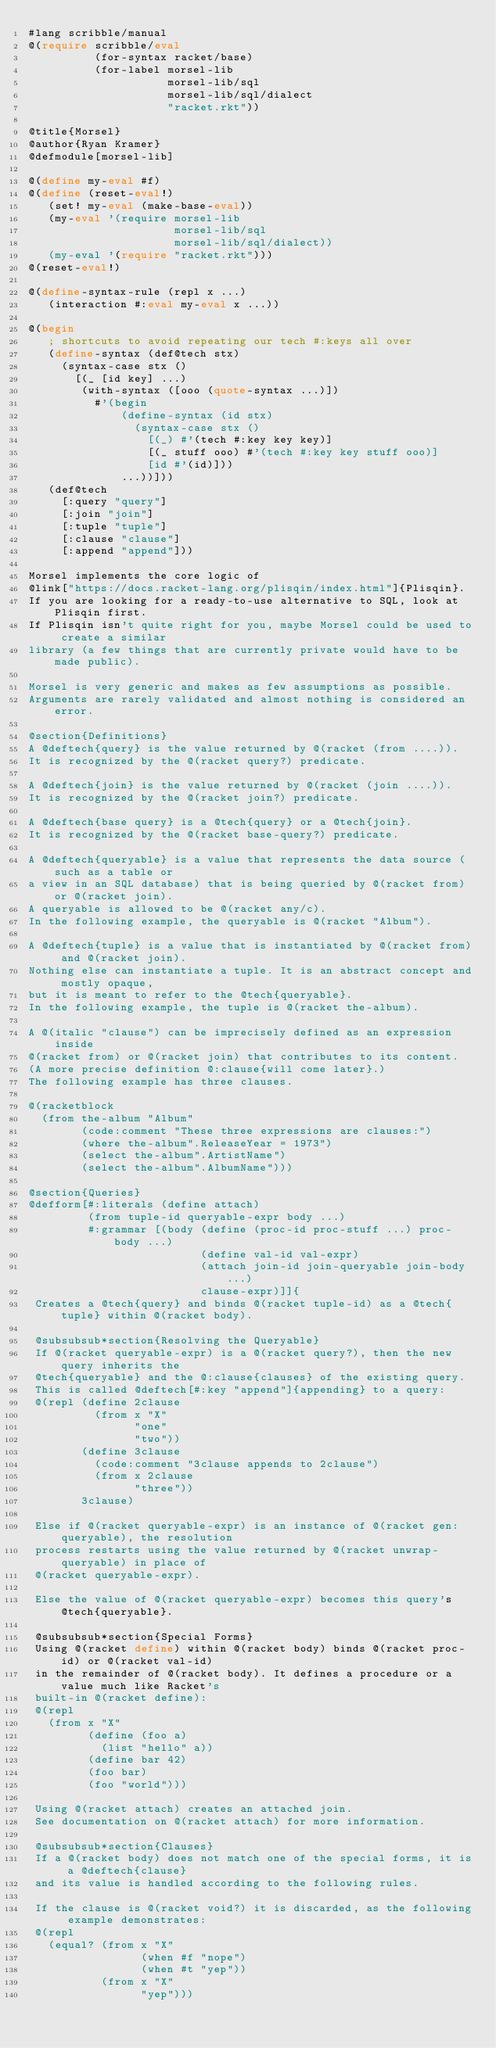<code> <loc_0><loc_0><loc_500><loc_500><_Racket_>#lang scribble/manual
@(require scribble/eval
          (for-syntax racket/base)
          (for-label morsel-lib
                     morsel-lib/sql
                     morsel-lib/sql/dialect
                     "racket.rkt"))

@title{Morsel}
@author{Ryan Kramer}
@defmodule[morsel-lib]

@(define my-eval #f)
@(define (reset-eval!)
   (set! my-eval (make-base-eval))
   (my-eval '(require morsel-lib
                      morsel-lib/sql
                      morsel-lib/sql/dialect))
   (my-eval '(require "racket.rkt")))
@(reset-eval!)

@(define-syntax-rule (repl x ...)
   (interaction #:eval my-eval x ...))

@(begin
   ; shortcuts to avoid repeating our tech #:keys all over
   (define-syntax (def@tech stx)
     (syntax-case stx ()
       [(_ [id key] ...)
        (with-syntax ([ooo (quote-syntax ...)])
          #'(begin
              (define-syntax (id stx)
                (syntax-case stx ()
                  [(_) #'(tech #:key key key)]
                  [(_ stuff ooo) #'(tech #:key key stuff ooo)]
                  [id #'(id)]))
              ...))]))
   (def@tech
     [:query "query"]
     [:join "join"]
     [:tuple "tuple"]
     [:clause "clause"]
     [:append "append"]))

Morsel implements the core logic of
@link["https://docs.racket-lang.org/plisqin/index.html"]{Plisqin}.
If you are looking for a ready-to-use alternative to SQL, look at Plisqin first.
If Plisqin isn't quite right for you, maybe Morsel could be used to create a similar
library (a few things that are currently private would have to be made public).

Morsel is very generic and makes as few assumptions as possible.
Arguments are rarely validated and almost nothing is considered an error.

@section{Definitions}
A @deftech{query} is the value returned by @(racket (from ....)).
It is recognized by the @(racket query?) predicate.

A @deftech{join} is the value returned by @(racket (join ....)).
It is recognized by the @(racket join?) predicate.

A @deftech{base query} is a @tech{query} or a @tech{join}.
It is recognized by the @(racket base-query?) predicate.

A @deftech{queryable} is a value that represents the data source (such as a table or
a view in an SQL database) that is being queried by @(racket from) or @(racket join).
A queryable is allowed to be @(racket any/c).
In the following example, the queryable is @(racket "Album").

A @deftech{tuple} is a value that is instantiated by @(racket from) and @(racket join).
Nothing else can instantiate a tuple. It is an abstract concept and mostly opaque,
but it is meant to refer to the @tech{queryable}.
In the following example, the tuple is @(racket the-album).

A @(italic "clause") can be imprecisely defined as an expression inside
@(racket from) or @(racket join) that contributes to its content.
(A more precise definition @:clause{will come later}.)
The following example has three clauses.

@(racketblock
  (from the-album "Album"
        (code:comment "These three expressions are clauses:")
        (where the-album".ReleaseYear = 1973")
        (select the-album".ArtistName")
        (select the-album".AlbumName")))

@section{Queries}
@defform[#:literals (define attach)
         (from tuple-id queryable-expr body ...)
         #:grammar [(body (define (proc-id proc-stuff ...) proc-body ...)
                          (define val-id val-expr)
                          (attach join-id join-queryable join-body ...)
                          clause-expr)]]{
 Creates a @tech{query} and binds @(racket tuple-id) as a @tech{tuple} within @(racket body).

 @subsubsub*section{Resolving the Queryable}
 If @(racket queryable-expr) is a @(racket query?), then the new query inherits the
 @tech{queryable} and the @:clause{clauses} of the existing query.
 This is called @deftech[#:key "append"]{appending} to a query:
 @(repl (define 2clause
          (from x "X"
                "one"
                "two"))
        (define 3clause
          (code:comment "3clause appends to 2clause")
          (from x 2clause
                "three"))
        3clause)

 Else if @(racket queryable-expr) is an instance of @(racket gen:queryable), the resolution
 process restarts using the value returned by @(racket unwrap-queryable) in place of
 @(racket queryable-expr).

 Else the value of @(racket queryable-expr) becomes this query's @tech{queryable}.

 @subsubsub*section{Special Forms}
 Using @(racket define) within @(racket body) binds @(racket proc-id) or @(racket val-id)
 in the remainder of @(racket body). It defines a procedure or a value much like Racket's
 built-in @(racket define):
 @(repl
   (from x "X"
         (define (foo a)
           (list "hello" a))
         (define bar 42)
         (foo bar)
         (foo "world")))

 Using @(racket attach) creates an attached join.
 See documentation on @(racket attach) for more information.

 @subsubsub*section{Clauses}
 If a @(racket body) does not match one of the special forms, it is a @deftech{clause}
 and its value is handled according to the following rules.

 If the clause is @(racket void?) it is discarded, as the following example demonstrates:
 @(repl
   (equal? (from x "X"
                 (when #f "nope")
                 (when #t "yep"))
           (from x "X"
                 "yep")))
</code> 